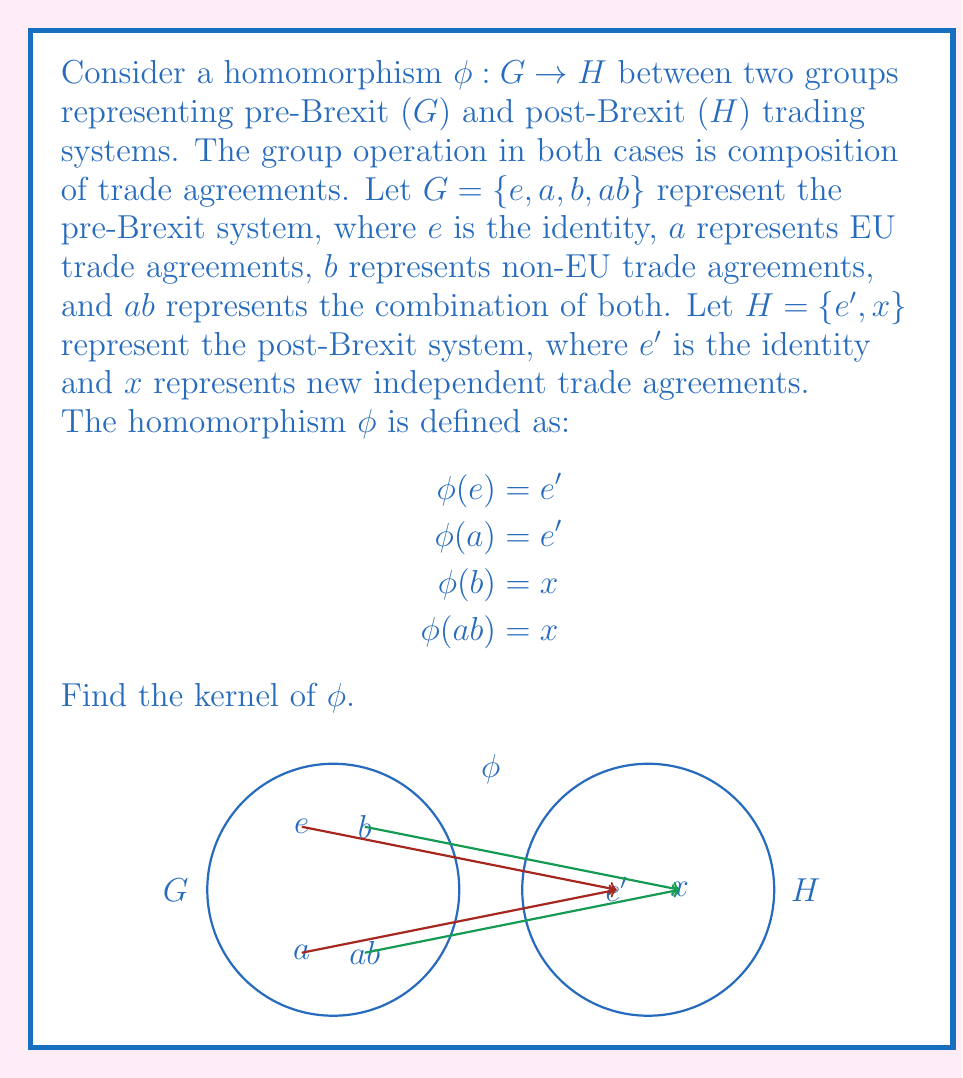Help me with this question. To find the kernel of the homomorphism $\phi$, we need to determine all elements in $G$ that map to the identity element $e'$ in $H$. Let's proceed step-by-step:

1) First, recall the definition of the kernel:
   $\text{ker}(\phi) = \{g \in G : \phi(g) = e'\}$

2) Now, let's examine each element of $G$:

   For $e$: $\phi(e) = e'$
   For $a$: $\phi(a) = e'$
   For $b$: $\phi(b) = x$
   For $ab$: $\phi(ab) = x$

3) We can see that both $e$ and $a$ map to $e'$ in $H$, while $b$ and $ab$ map to $x$.

4) Therefore, the elements of $G$ that map to the identity $e'$ in $H$ are $e$ and $a$.

5) Thus, the kernel of $\phi$ is $\{e, a\}$.

This result shows that the EU trade agreements (represented by $a$) become equivalent to the identity element in the post-Brexit system, reflecting the potential loss of these agreements after Brexit.
Answer: $\text{ker}(\phi) = \{e, a\}$ 